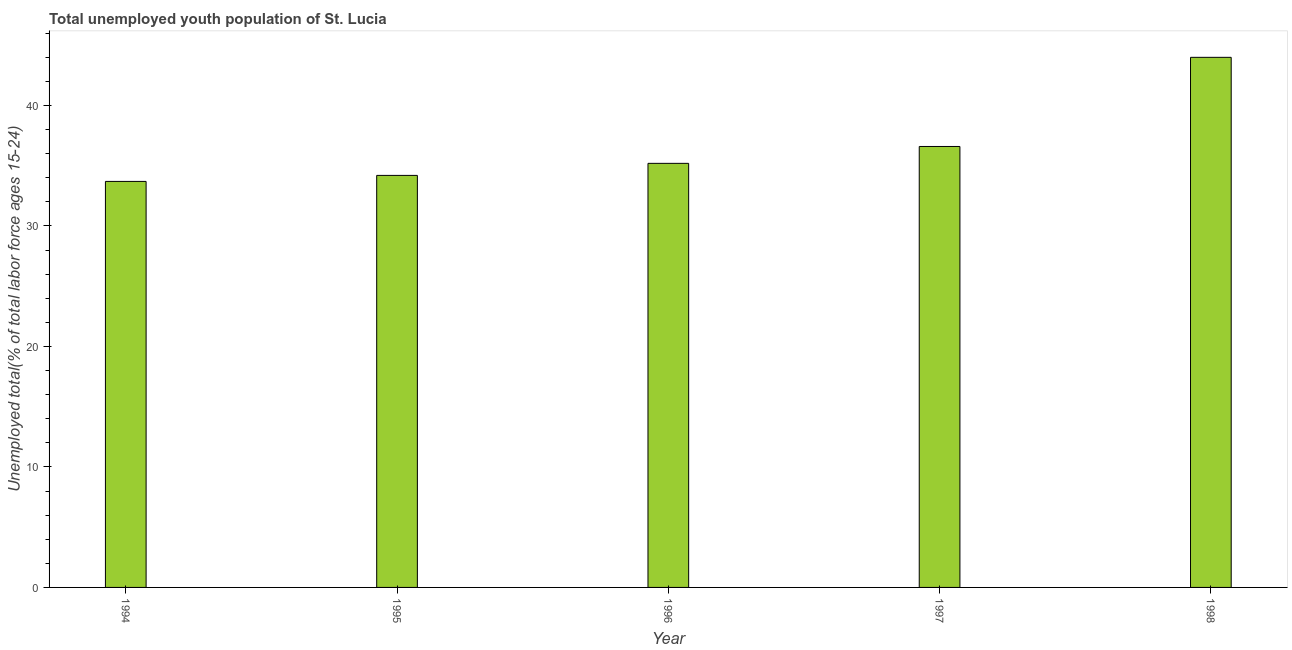What is the title of the graph?
Ensure brevity in your answer.  Total unemployed youth population of St. Lucia. What is the label or title of the X-axis?
Ensure brevity in your answer.  Year. What is the label or title of the Y-axis?
Keep it short and to the point. Unemployed total(% of total labor force ages 15-24). Across all years, what is the maximum unemployed youth?
Offer a very short reply. 44. Across all years, what is the minimum unemployed youth?
Offer a very short reply. 33.7. In which year was the unemployed youth maximum?
Your answer should be compact. 1998. What is the sum of the unemployed youth?
Your answer should be very brief. 183.7. What is the difference between the unemployed youth in 1995 and 1996?
Your answer should be compact. -1. What is the average unemployed youth per year?
Give a very brief answer. 36.74. What is the median unemployed youth?
Keep it short and to the point. 35.2. In how many years, is the unemployed youth greater than 38 %?
Provide a succinct answer. 1. What is the ratio of the unemployed youth in 1994 to that in 1997?
Provide a short and direct response. 0.92. Is the unemployed youth in 1995 less than that in 1997?
Your response must be concise. Yes. Is the difference between the unemployed youth in 1994 and 1995 greater than the difference between any two years?
Provide a short and direct response. No. What is the difference between the highest and the second highest unemployed youth?
Give a very brief answer. 7.4. What is the difference between the highest and the lowest unemployed youth?
Your response must be concise. 10.3. In how many years, is the unemployed youth greater than the average unemployed youth taken over all years?
Your answer should be compact. 1. How many bars are there?
Provide a succinct answer. 5. What is the difference between two consecutive major ticks on the Y-axis?
Your answer should be very brief. 10. What is the Unemployed total(% of total labor force ages 15-24) of 1994?
Make the answer very short. 33.7. What is the Unemployed total(% of total labor force ages 15-24) in 1995?
Keep it short and to the point. 34.2. What is the Unemployed total(% of total labor force ages 15-24) in 1996?
Provide a short and direct response. 35.2. What is the Unemployed total(% of total labor force ages 15-24) in 1997?
Your answer should be compact. 36.6. What is the Unemployed total(% of total labor force ages 15-24) of 1998?
Ensure brevity in your answer.  44. What is the difference between the Unemployed total(% of total labor force ages 15-24) in 1994 and 1996?
Offer a very short reply. -1.5. What is the difference between the Unemployed total(% of total labor force ages 15-24) in 1994 and 1997?
Offer a very short reply. -2.9. What is the difference between the Unemployed total(% of total labor force ages 15-24) in 1996 and 1997?
Offer a terse response. -1.4. What is the difference between the Unemployed total(% of total labor force ages 15-24) in 1996 and 1998?
Your answer should be very brief. -8.8. What is the difference between the Unemployed total(% of total labor force ages 15-24) in 1997 and 1998?
Ensure brevity in your answer.  -7.4. What is the ratio of the Unemployed total(% of total labor force ages 15-24) in 1994 to that in 1995?
Ensure brevity in your answer.  0.98. What is the ratio of the Unemployed total(% of total labor force ages 15-24) in 1994 to that in 1996?
Keep it short and to the point. 0.96. What is the ratio of the Unemployed total(% of total labor force ages 15-24) in 1994 to that in 1997?
Offer a terse response. 0.92. What is the ratio of the Unemployed total(% of total labor force ages 15-24) in 1994 to that in 1998?
Make the answer very short. 0.77. What is the ratio of the Unemployed total(% of total labor force ages 15-24) in 1995 to that in 1996?
Offer a terse response. 0.97. What is the ratio of the Unemployed total(% of total labor force ages 15-24) in 1995 to that in 1997?
Provide a short and direct response. 0.93. What is the ratio of the Unemployed total(% of total labor force ages 15-24) in 1995 to that in 1998?
Your response must be concise. 0.78. What is the ratio of the Unemployed total(% of total labor force ages 15-24) in 1996 to that in 1998?
Offer a terse response. 0.8. What is the ratio of the Unemployed total(% of total labor force ages 15-24) in 1997 to that in 1998?
Your response must be concise. 0.83. 